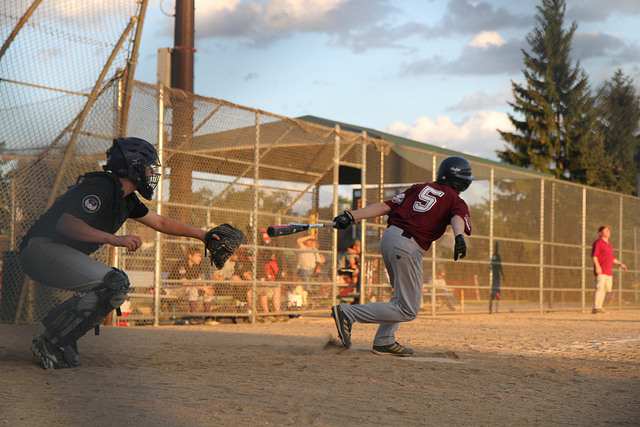Read and extract the text from this image. 5 